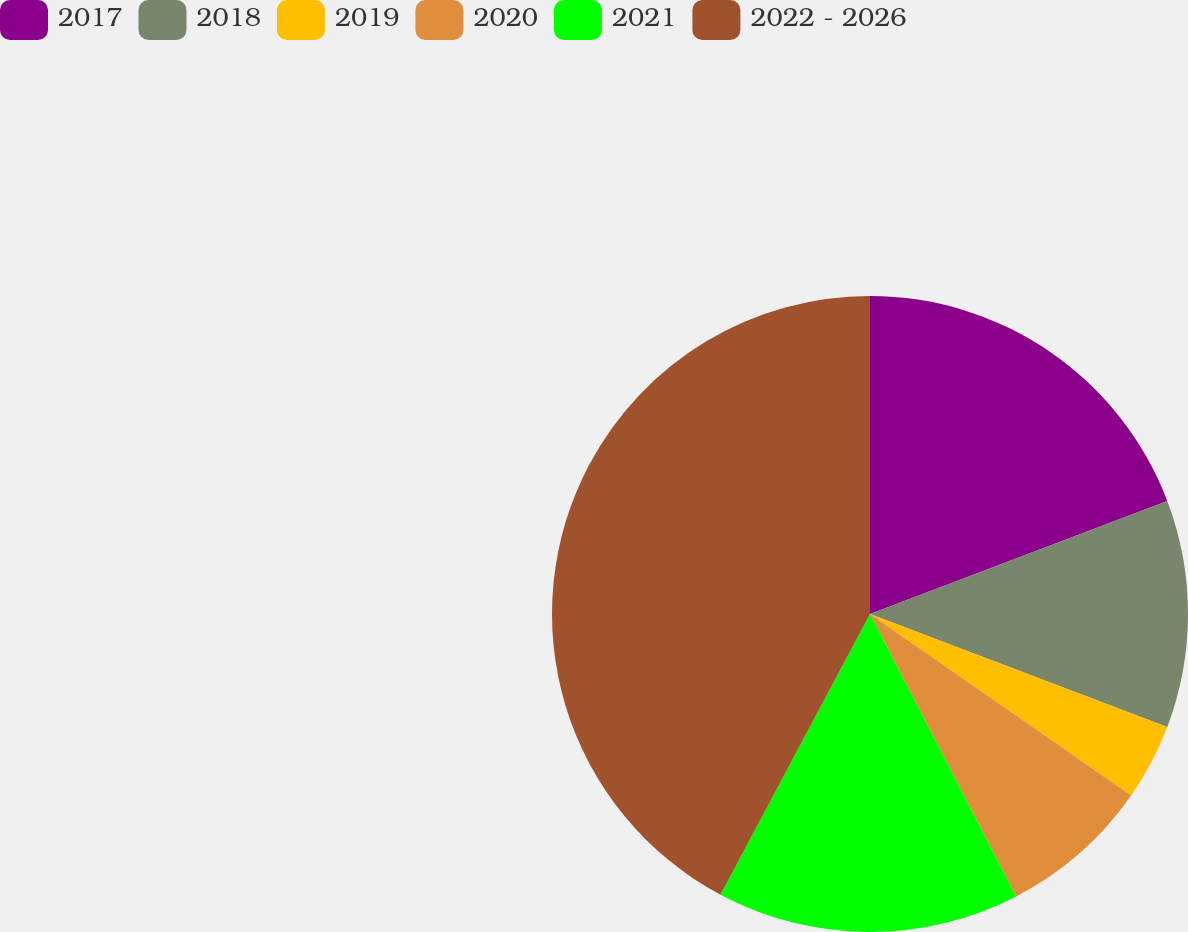Convert chart to OTSL. <chart><loc_0><loc_0><loc_500><loc_500><pie_chart><fcel>2017<fcel>2018<fcel>2019<fcel>2020<fcel>2021<fcel>2022 - 2026<nl><fcel>19.22%<fcel>11.56%<fcel>3.89%<fcel>7.73%<fcel>15.39%<fcel>42.21%<nl></chart> 